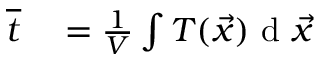Convert formula to latex. <formula><loc_0><loc_0><loc_500><loc_500>\begin{array} { r l } { \overline { t } } & = \frac { 1 } { V } \int T ( \vec { x } ) d \vec { x } } \end{array}</formula> 